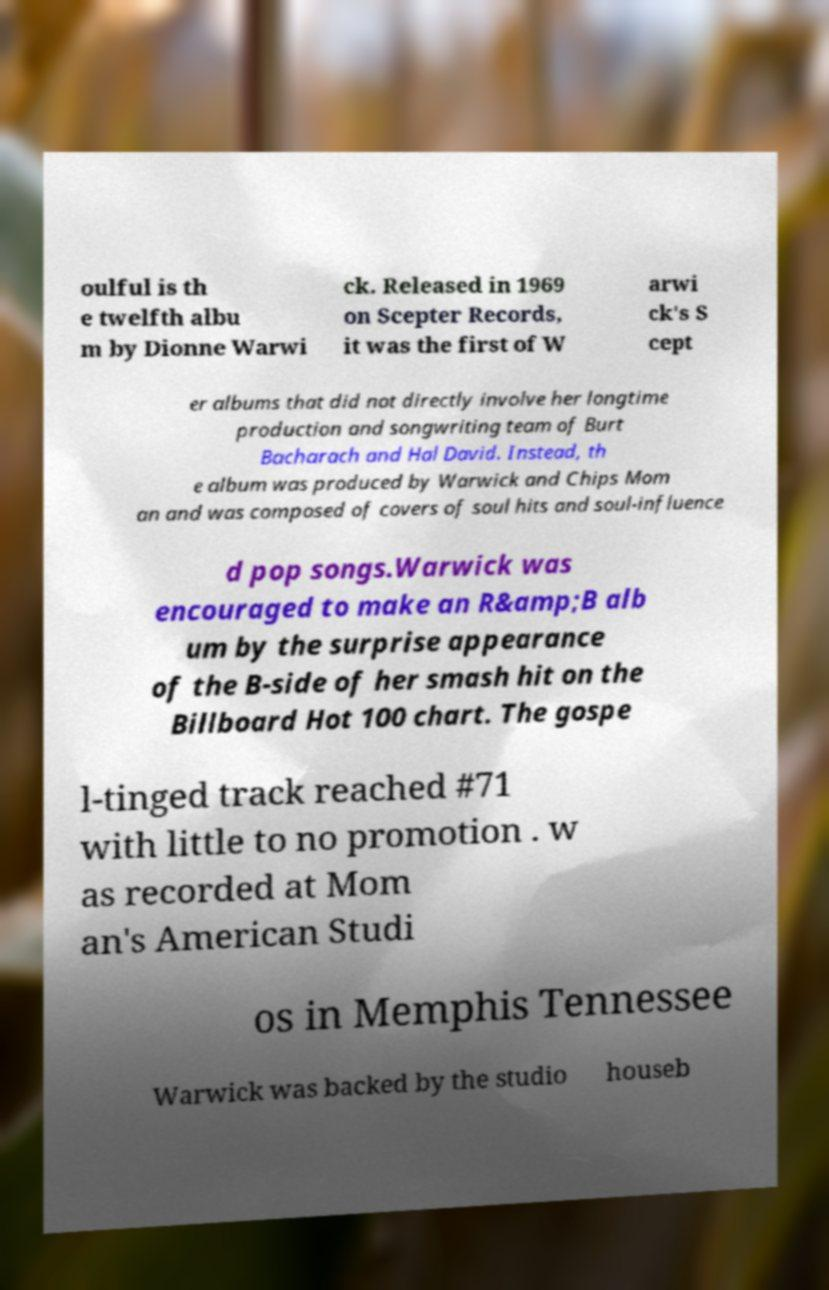What messages or text are displayed in this image? I need them in a readable, typed format. oulful is th e twelfth albu m by Dionne Warwi ck. Released in 1969 on Scepter Records, it was the first of W arwi ck's S cept er albums that did not directly involve her longtime production and songwriting team of Burt Bacharach and Hal David. Instead, th e album was produced by Warwick and Chips Mom an and was composed of covers of soul hits and soul-influence d pop songs.Warwick was encouraged to make an R&amp;B alb um by the surprise appearance of the B-side of her smash hit on the Billboard Hot 100 chart. The gospe l-tinged track reached #71 with little to no promotion . w as recorded at Mom an's American Studi os in Memphis Tennessee Warwick was backed by the studio houseb 